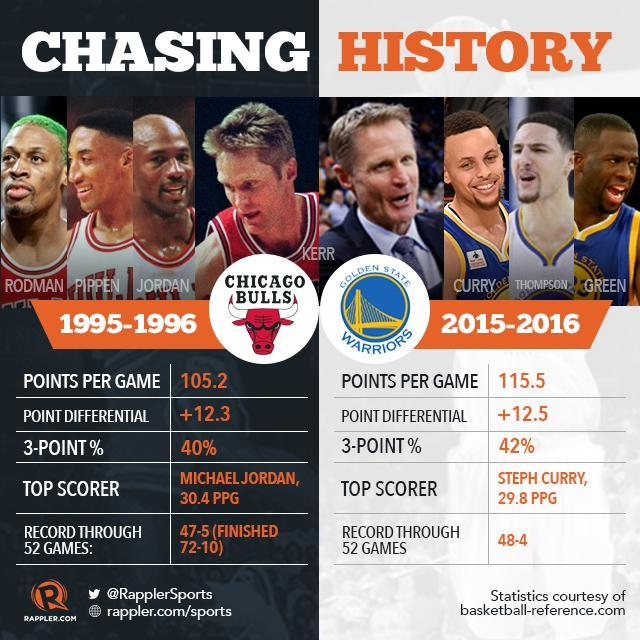Who is the top scorer of of Golden state warriors and what was his score?
Answer the question with a short phrase. Steph Curry, 29.8 PPG Who was the Chicago Bulls player who went on to become the coach of Golden State Warriors? Kerr What was the point differential for Golden state Warriors? +12.5 What was the record through 52 games for Chicago Bulls? 47-5 Who is the top scorer of Chicago Bulls and what was his score? Michael Jordan, 30.4 PPG What was the points per game for Chicago Bulls? 105.2 What is the percentage of 3 pointers for Golden state Warriors? 42% What is the percentage of 3 pointers for the Chicago Bulls? 40% Who has a higher  3-Point %? Golden state Warriors Who is chasing history here? Kerr What was the point differential for Chicago Bulls? +12.3 Who has a higher point differential? Golden state Warriors What was the points per game for the Warriors? 115.5 What was the record through 52 games for Golden state warriors? 48-4 